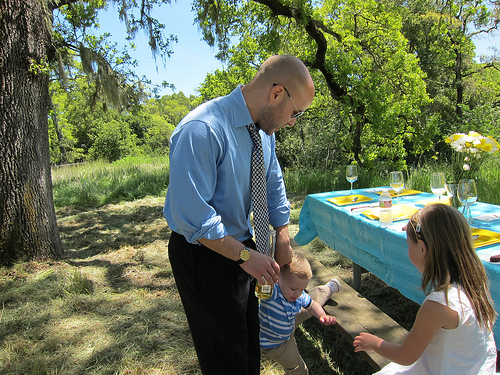<image>
Is the water on the girl? No. The water is not positioned on the girl. They may be near each other, but the water is not supported by or resting on top of the girl. Is there a man on the table? No. The man is not positioned on the table. They may be near each other, but the man is not supported by or resting on top of the table. Is there a tree behind the table? Yes. From this viewpoint, the tree is positioned behind the table, with the table partially or fully occluding the tree. 